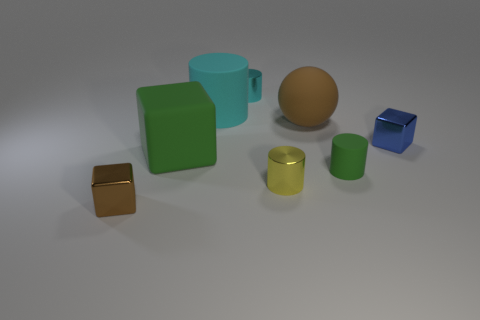Add 2 green matte objects. How many objects exist? 10 Subtract all cubes. How many objects are left? 5 Add 7 matte cylinders. How many matte cylinders exist? 9 Subtract 1 brown blocks. How many objects are left? 7 Subtract all small yellow metal things. Subtract all tiny green objects. How many objects are left? 6 Add 8 tiny yellow things. How many tiny yellow things are left? 9 